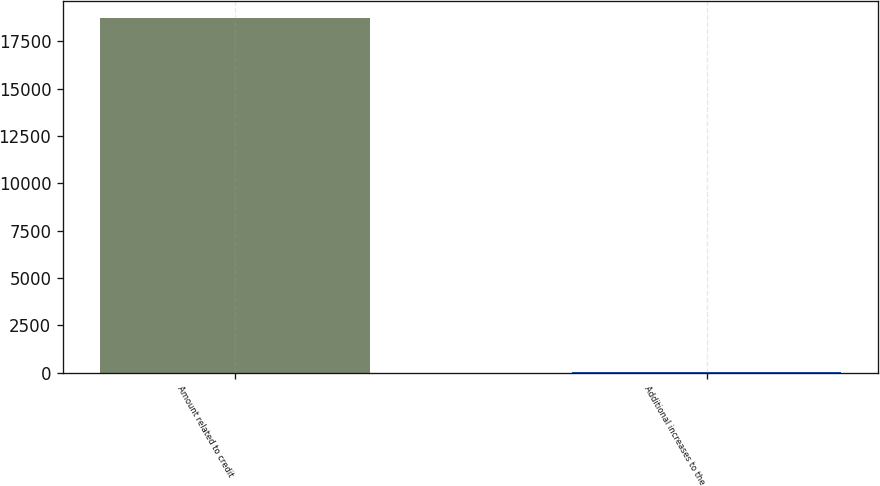Convert chart to OTSL. <chart><loc_0><loc_0><loc_500><loc_500><bar_chart><fcel>Amount related to credit<fcel>Additional increases to the<nl><fcel>18703<fcel>27<nl></chart> 